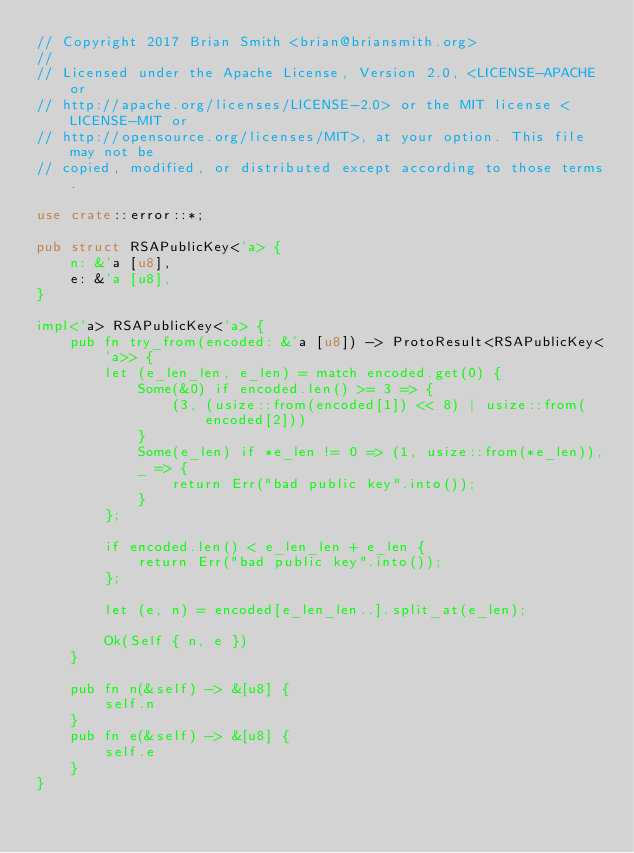Convert code to text. <code><loc_0><loc_0><loc_500><loc_500><_Rust_>// Copyright 2017 Brian Smith <brian@briansmith.org>
//
// Licensed under the Apache License, Version 2.0, <LICENSE-APACHE or
// http://apache.org/licenses/LICENSE-2.0> or the MIT license <LICENSE-MIT or
// http://opensource.org/licenses/MIT>, at your option. This file may not be
// copied, modified, or distributed except according to those terms.

use crate::error::*;

pub struct RSAPublicKey<'a> {
    n: &'a [u8],
    e: &'a [u8],
}

impl<'a> RSAPublicKey<'a> {
    pub fn try_from(encoded: &'a [u8]) -> ProtoResult<RSAPublicKey<'a>> {
        let (e_len_len, e_len) = match encoded.get(0) {
            Some(&0) if encoded.len() >= 3 => {
                (3, (usize::from(encoded[1]) << 8) | usize::from(encoded[2]))
            }
            Some(e_len) if *e_len != 0 => (1, usize::from(*e_len)),
            _ => {
                return Err("bad public key".into());
            }
        };

        if encoded.len() < e_len_len + e_len {
            return Err("bad public key".into());
        };

        let (e, n) = encoded[e_len_len..].split_at(e_len);

        Ok(Self { n, e })
    }

    pub fn n(&self) -> &[u8] {
        self.n
    }
    pub fn e(&self) -> &[u8] {
        self.e
    }
}
</code> 